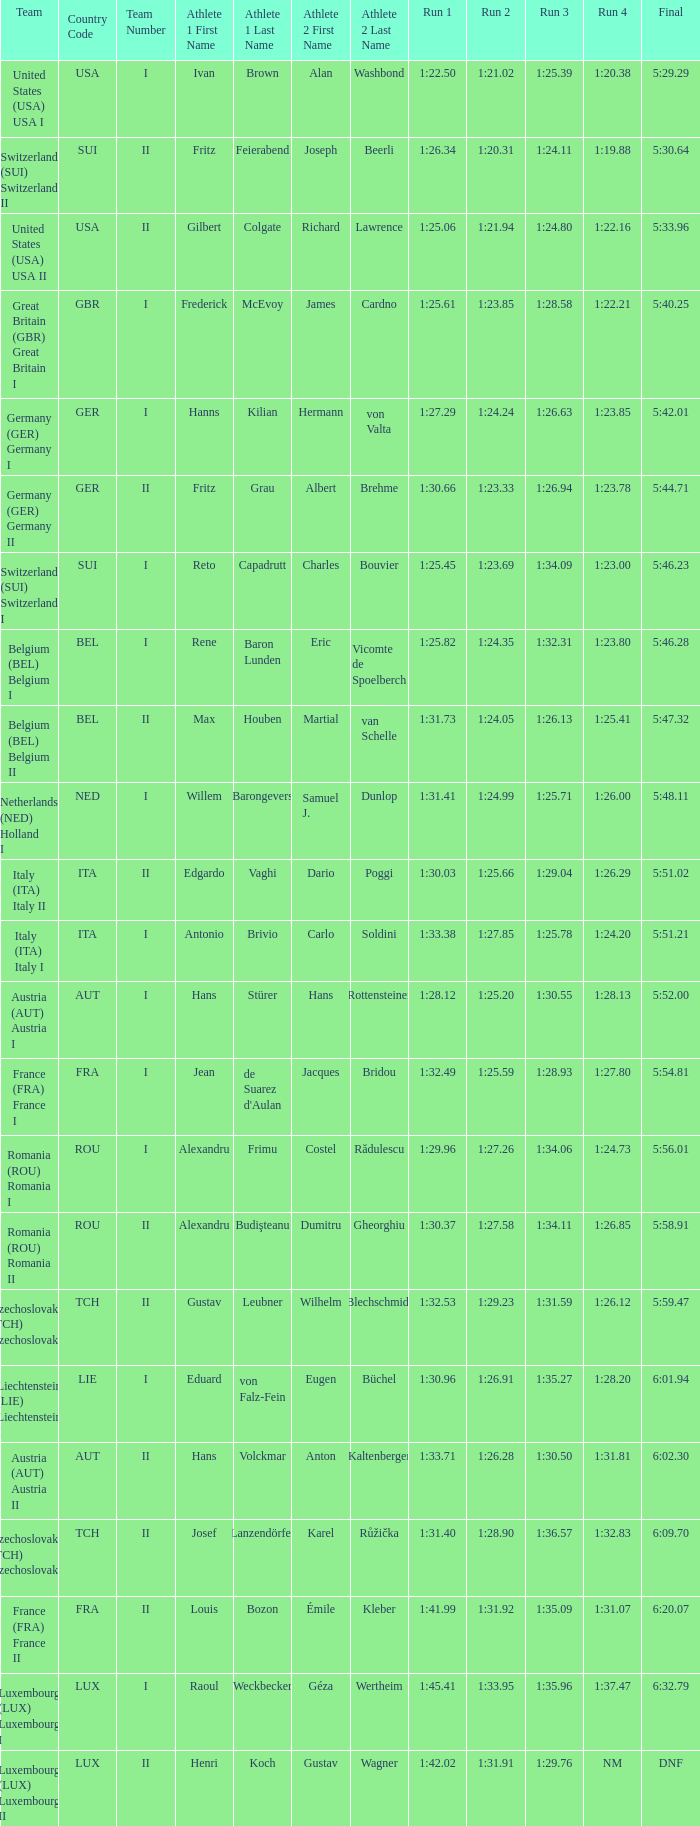Which run 4 possesses a run 3 duration of 1:2 1:23.85. 